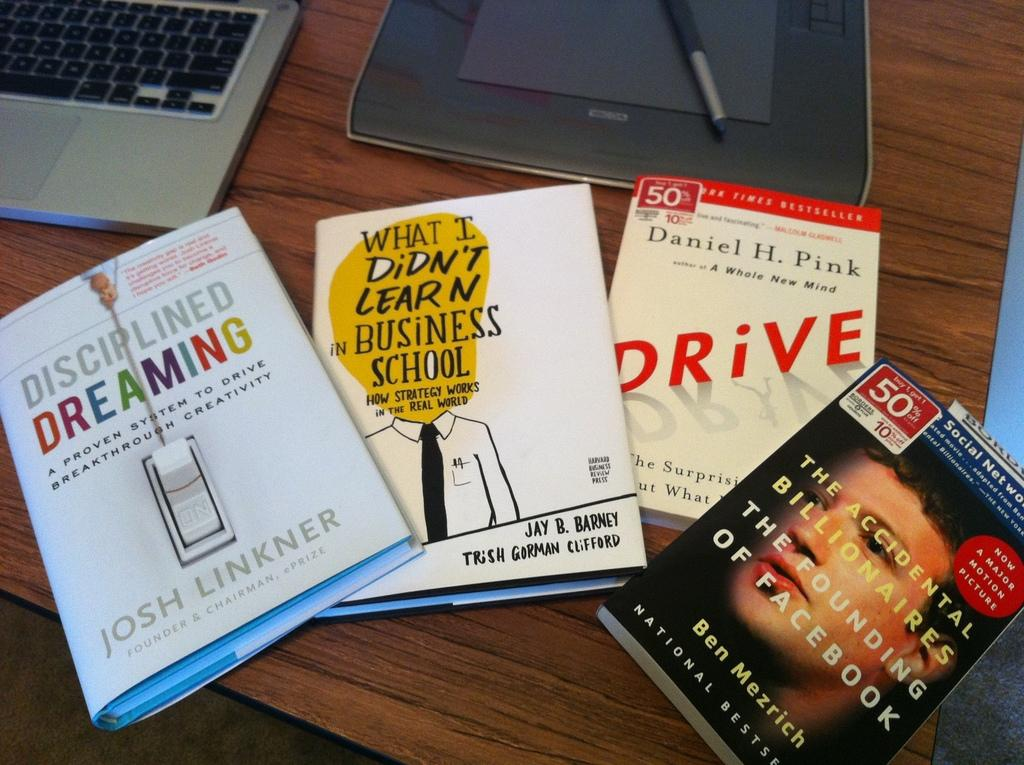<image>
Summarize the visual content of the image. A collection of four books with one titled Disciplined Dreaming. 